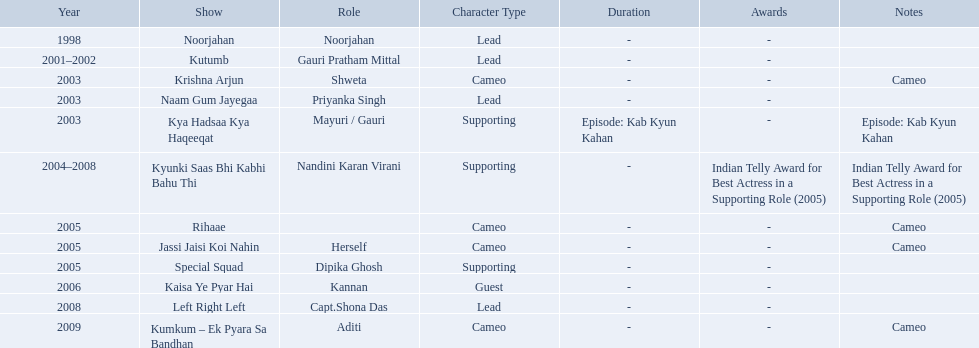What shows was gauri tejwani in? Noorjahan, Kutumb, Krishna Arjun, Naam Gum Jayegaa, Kya Hadsaa Kya Haqeeqat, Kyunki Saas Bhi Kabhi Bahu Thi, Rihaae, Jassi Jaisi Koi Nahin, Special Squad, Kaisa Ye Pyar Hai, Left Right Left, Kumkum – Ek Pyara Sa Bandhan. What were the 2005 shows? Rihaae, Jassi Jaisi Koi Nahin, Special Squad. Which were cameos? Rihaae, Jassi Jaisi Koi Nahin. Of which of these it was not rihaee? Jassi Jaisi Koi Nahin. What shows did gauri pradhan tejwani star in? Noorjahan, Kutumb, Krishna Arjun, Naam Gum Jayegaa, Kya Hadsaa Kya Haqeeqat, Kyunki Saas Bhi Kabhi Bahu Thi, Rihaae, Jassi Jaisi Koi Nahin, Special Squad, Kaisa Ye Pyar Hai, Left Right Left, Kumkum – Ek Pyara Sa Bandhan. Of these, which were cameos? Krishna Arjun, Rihaae, Jassi Jaisi Koi Nahin, Kumkum – Ek Pyara Sa Bandhan. Of these, in which did she play the role of herself? Jassi Jaisi Koi Nahin. How many shows are there? Noorjahan, Kutumb, Krishna Arjun, Naam Gum Jayegaa, Kya Hadsaa Kya Haqeeqat, Kyunki Saas Bhi Kabhi Bahu Thi, Rihaae, Jassi Jaisi Koi Nahin, Special Squad, Kaisa Ye Pyar Hai, Left Right Left, Kumkum – Ek Pyara Sa Bandhan. How many shows did she make a cameo appearance? Krishna Arjun, Rihaae, Jassi Jaisi Koi Nahin, Kumkum – Ek Pyara Sa Bandhan. Of those, how many did she play herself? Jassi Jaisi Koi Nahin. What are all of the shows? Noorjahan, Kutumb, Krishna Arjun, Naam Gum Jayegaa, Kya Hadsaa Kya Haqeeqat, Kyunki Saas Bhi Kabhi Bahu Thi, Rihaae, Jassi Jaisi Koi Nahin, Special Squad, Kaisa Ye Pyar Hai, Left Right Left, Kumkum – Ek Pyara Sa Bandhan. When were they in production? 1998, 2001–2002, 2003, 2003, 2003, 2004–2008, 2005, 2005, 2005, 2006, 2008, 2009. And which show was he on for the longest time? Kyunki Saas Bhi Kabhi Bahu Thi. 